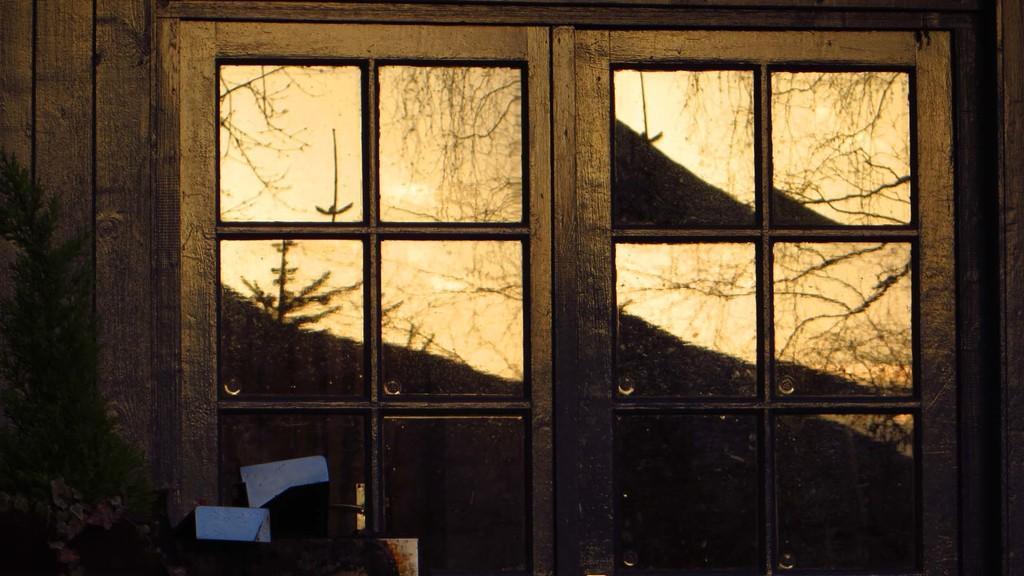Describe this image in one or two sentences. In this image we can see windows to the wooden wall and in front of the wall there is a tree and we can see the reflection of trees in the glass of a window. 